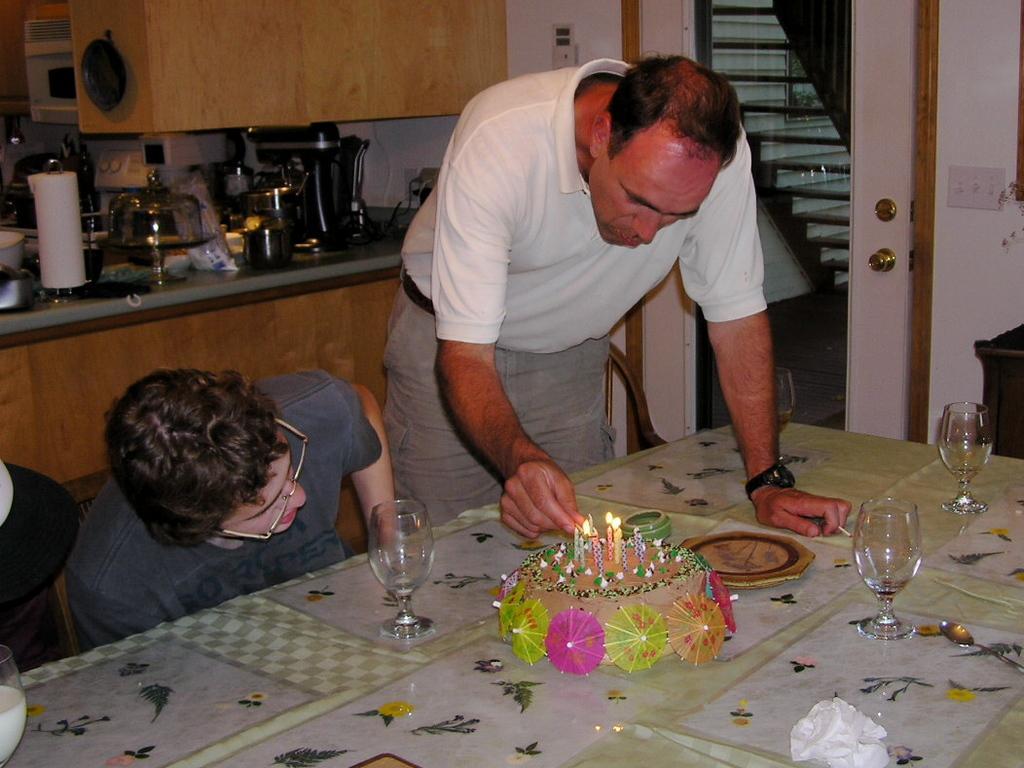Describe this image in one or two sentences. In this image I can see a person wearing a white t-shirt and grey pant Standing and holding a matchstick in his hand, and a person wearing a t-shirt sitting on a chair in front of a table, on the table I can see few glasses, tissue paper and a cake with few candles on it. In the background I can see a kitchen counter top, a coffee maker, few utensils, a wooden cupboard, microwave oven, the wall ,the door and the switch board. 